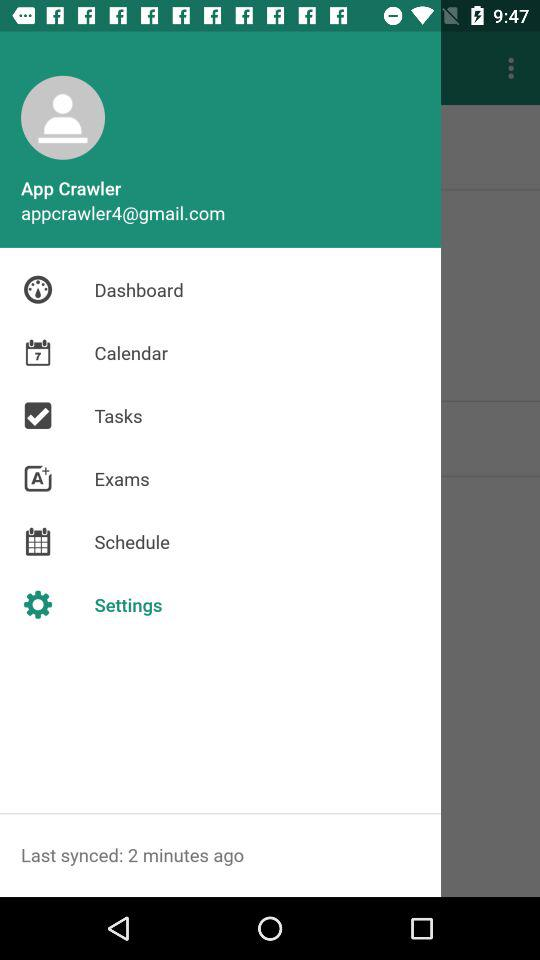What is the email address? The email address is appcrawler4@gmail.com. 